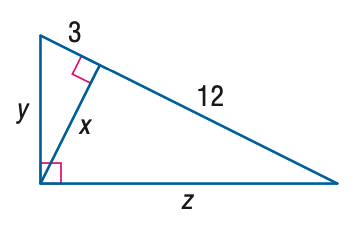Answer the mathemtical geometry problem and directly provide the correct option letter.
Question: Find y.
Choices: A: 3 B: 3 \sqrt { 3 } C: 6 D: 3 \sqrt { 5 } D 